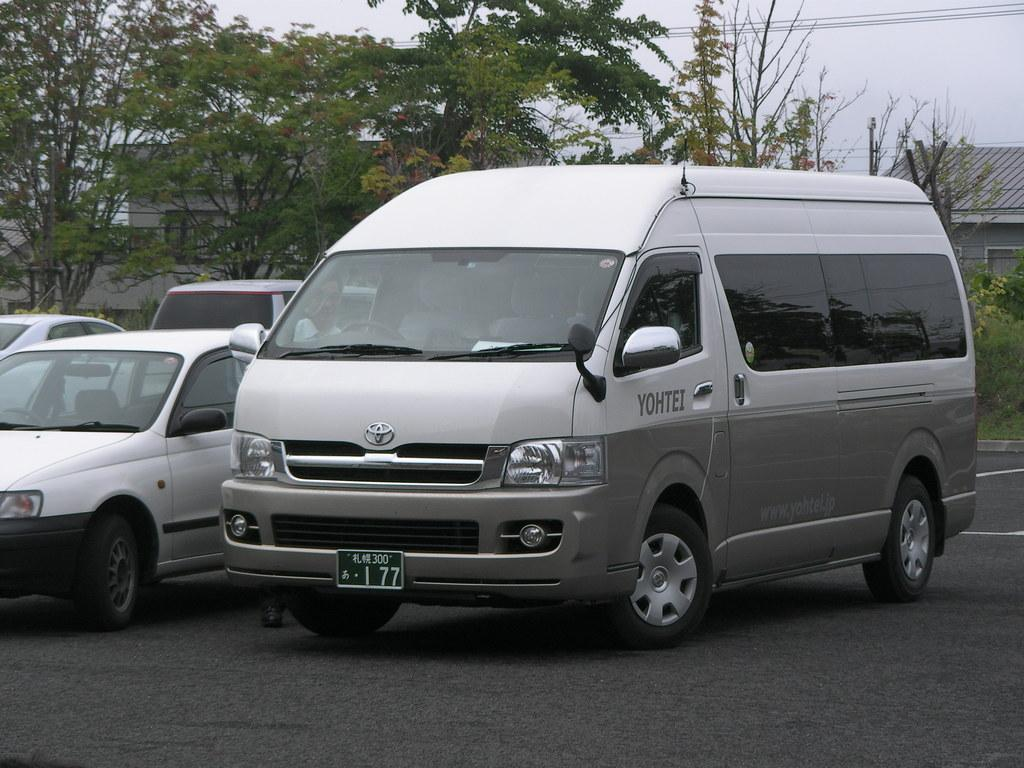<image>
Give a short and clear explanation of the subsequent image. A grey van is in a parking lot and it says Yohtei on the driver side door. 